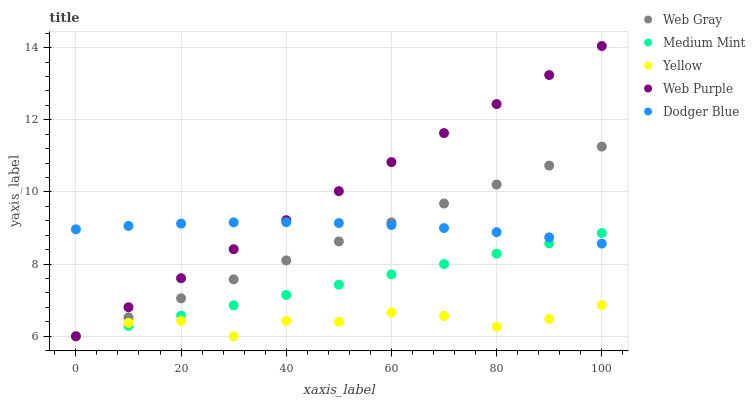Does Yellow have the minimum area under the curve?
Answer yes or no. Yes. Does Web Purple have the maximum area under the curve?
Answer yes or no. Yes. Does Web Gray have the minimum area under the curve?
Answer yes or no. No. Does Web Gray have the maximum area under the curve?
Answer yes or no. No. Is Web Purple the smoothest?
Answer yes or no. Yes. Is Yellow the roughest?
Answer yes or no. Yes. Is Web Gray the smoothest?
Answer yes or no. No. Is Web Gray the roughest?
Answer yes or no. No. Does Medium Mint have the lowest value?
Answer yes or no. Yes. Does Dodger Blue have the lowest value?
Answer yes or no. No. Does Web Purple have the highest value?
Answer yes or no. Yes. Does Web Gray have the highest value?
Answer yes or no. No. Is Yellow less than Dodger Blue?
Answer yes or no. Yes. Is Dodger Blue greater than Yellow?
Answer yes or no. Yes. Does Yellow intersect Web Purple?
Answer yes or no. Yes. Is Yellow less than Web Purple?
Answer yes or no. No. Is Yellow greater than Web Purple?
Answer yes or no. No. Does Yellow intersect Dodger Blue?
Answer yes or no. No. 